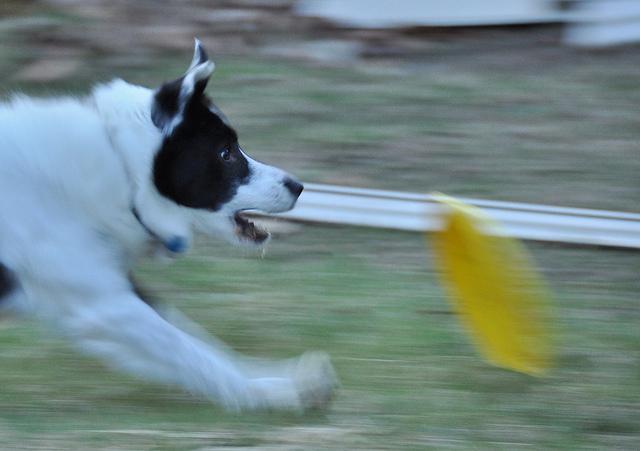Why is the dog's mouth open?
Concise answer only. To catch frisbee. Is this dog playing catch frisbee?
Be succinct. Yes. What is the dog looking at?
Quick response, please. Frisbee. What color is the frisbee?
Write a very short answer. Yellow. 